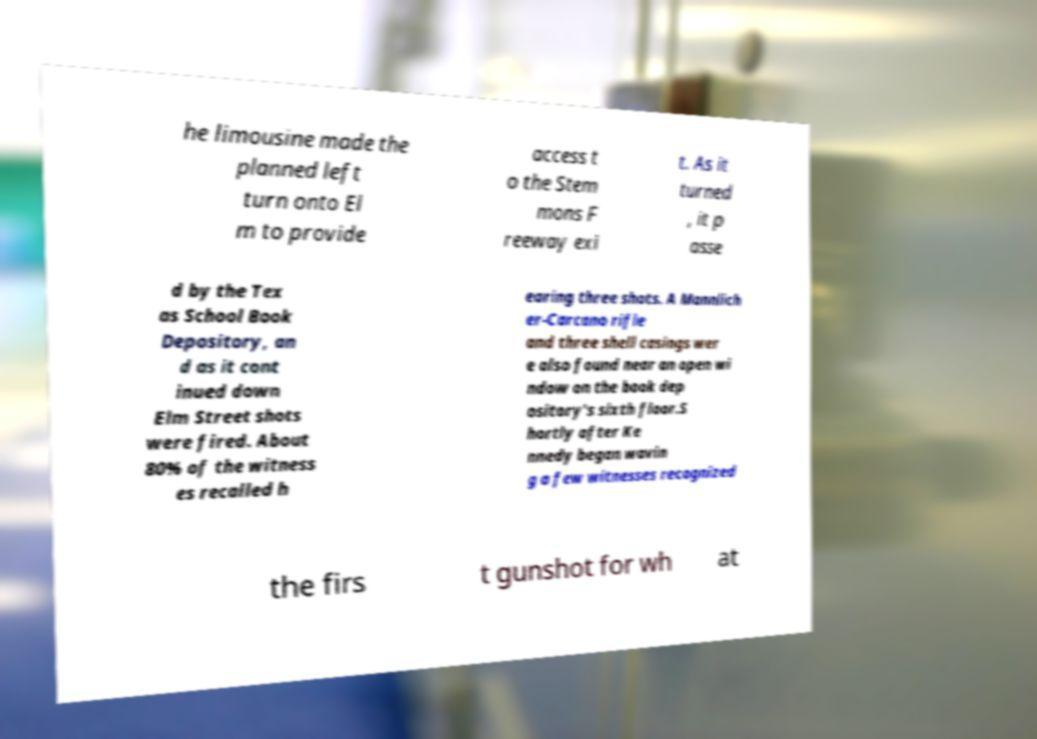Could you extract and type out the text from this image? he limousine made the planned left turn onto El m to provide access t o the Stem mons F reeway exi t. As it turned , it p asse d by the Tex as School Book Depository, an d as it cont inued down Elm Street shots were fired. About 80% of the witness es recalled h earing three shots. A Mannlich er-Carcano rifle and three shell casings wer e also found near an open wi ndow on the book dep ository's sixth floor.S hortly after Ke nnedy began wavin g a few witnesses recognized the firs t gunshot for wh at 